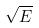<formula> <loc_0><loc_0><loc_500><loc_500>\sqrt { E }</formula> 